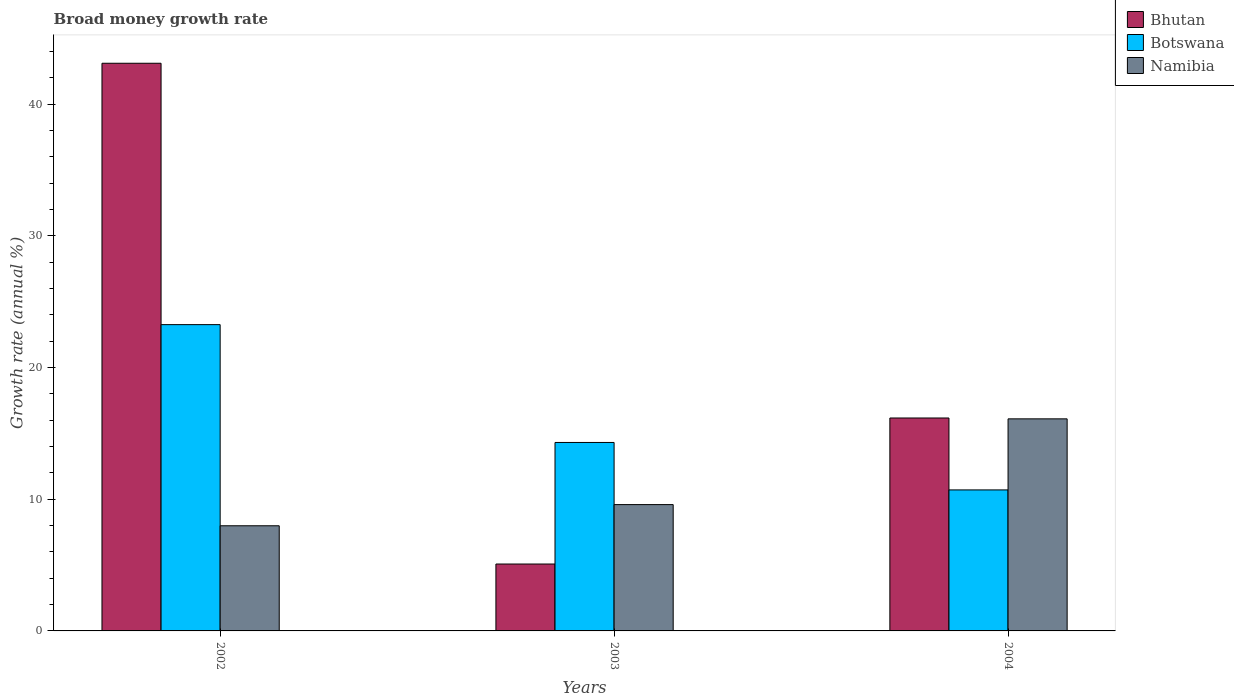How many different coloured bars are there?
Keep it short and to the point. 3. How many groups of bars are there?
Your answer should be very brief. 3. Are the number of bars per tick equal to the number of legend labels?
Keep it short and to the point. Yes. How many bars are there on the 2nd tick from the left?
Your response must be concise. 3. How many bars are there on the 3rd tick from the right?
Give a very brief answer. 3. In how many cases, is the number of bars for a given year not equal to the number of legend labels?
Your answer should be compact. 0. What is the growth rate in Botswana in 2002?
Your response must be concise. 23.26. Across all years, what is the maximum growth rate in Botswana?
Your answer should be compact. 23.26. Across all years, what is the minimum growth rate in Bhutan?
Your response must be concise. 5.08. In which year was the growth rate in Namibia minimum?
Offer a terse response. 2002. What is the total growth rate in Botswana in the graph?
Provide a short and direct response. 48.29. What is the difference between the growth rate in Botswana in 2003 and that in 2004?
Your answer should be compact. 3.6. What is the difference between the growth rate in Namibia in 2003 and the growth rate in Bhutan in 2002?
Make the answer very short. -33.52. What is the average growth rate in Namibia per year?
Offer a terse response. 11.23. In the year 2002, what is the difference between the growth rate in Bhutan and growth rate in Botswana?
Your answer should be very brief. 19.85. In how many years, is the growth rate in Namibia greater than 4 %?
Offer a very short reply. 3. What is the ratio of the growth rate in Bhutan in 2002 to that in 2003?
Keep it short and to the point. 8.49. Is the growth rate in Bhutan in 2002 less than that in 2004?
Offer a very short reply. No. Is the difference between the growth rate in Bhutan in 2002 and 2003 greater than the difference between the growth rate in Botswana in 2002 and 2003?
Make the answer very short. Yes. What is the difference between the highest and the second highest growth rate in Bhutan?
Your answer should be very brief. 26.94. What is the difference between the highest and the lowest growth rate in Bhutan?
Your response must be concise. 38.04. In how many years, is the growth rate in Botswana greater than the average growth rate in Botswana taken over all years?
Make the answer very short. 1. What does the 2nd bar from the left in 2004 represents?
Provide a succinct answer. Botswana. What does the 2nd bar from the right in 2003 represents?
Your response must be concise. Botswana. How many bars are there?
Provide a short and direct response. 9. What is the difference between two consecutive major ticks on the Y-axis?
Ensure brevity in your answer.  10. Are the values on the major ticks of Y-axis written in scientific E-notation?
Ensure brevity in your answer.  No. Does the graph contain any zero values?
Offer a very short reply. No. Does the graph contain grids?
Provide a short and direct response. No. How many legend labels are there?
Your response must be concise. 3. How are the legend labels stacked?
Offer a very short reply. Vertical. What is the title of the graph?
Your answer should be compact. Broad money growth rate. What is the label or title of the X-axis?
Make the answer very short. Years. What is the label or title of the Y-axis?
Your response must be concise. Growth rate (annual %). What is the Growth rate (annual %) in Bhutan in 2002?
Your response must be concise. 43.12. What is the Growth rate (annual %) in Botswana in 2002?
Make the answer very short. 23.26. What is the Growth rate (annual %) in Namibia in 2002?
Your answer should be very brief. 7.99. What is the Growth rate (annual %) in Bhutan in 2003?
Ensure brevity in your answer.  5.08. What is the Growth rate (annual %) in Botswana in 2003?
Your response must be concise. 14.31. What is the Growth rate (annual %) of Namibia in 2003?
Your answer should be very brief. 9.59. What is the Growth rate (annual %) in Bhutan in 2004?
Give a very brief answer. 16.17. What is the Growth rate (annual %) in Botswana in 2004?
Keep it short and to the point. 10.71. What is the Growth rate (annual %) in Namibia in 2004?
Make the answer very short. 16.11. Across all years, what is the maximum Growth rate (annual %) in Bhutan?
Your answer should be compact. 43.12. Across all years, what is the maximum Growth rate (annual %) of Botswana?
Provide a short and direct response. 23.26. Across all years, what is the maximum Growth rate (annual %) of Namibia?
Your answer should be compact. 16.11. Across all years, what is the minimum Growth rate (annual %) of Bhutan?
Offer a terse response. 5.08. Across all years, what is the minimum Growth rate (annual %) of Botswana?
Keep it short and to the point. 10.71. Across all years, what is the minimum Growth rate (annual %) in Namibia?
Provide a succinct answer. 7.99. What is the total Growth rate (annual %) of Bhutan in the graph?
Ensure brevity in your answer.  64.37. What is the total Growth rate (annual %) of Botswana in the graph?
Keep it short and to the point. 48.29. What is the total Growth rate (annual %) of Namibia in the graph?
Ensure brevity in your answer.  33.69. What is the difference between the Growth rate (annual %) of Bhutan in 2002 and that in 2003?
Make the answer very short. 38.04. What is the difference between the Growth rate (annual %) in Botswana in 2002 and that in 2003?
Provide a short and direct response. 8.95. What is the difference between the Growth rate (annual %) of Namibia in 2002 and that in 2003?
Offer a terse response. -1.61. What is the difference between the Growth rate (annual %) in Bhutan in 2002 and that in 2004?
Give a very brief answer. 26.94. What is the difference between the Growth rate (annual %) of Botswana in 2002 and that in 2004?
Your answer should be compact. 12.55. What is the difference between the Growth rate (annual %) of Namibia in 2002 and that in 2004?
Keep it short and to the point. -8.12. What is the difference between the Growth rate (annual %) of Bhutan in 2003 and that in 2004?
Provide a succinct answer. -11.09. What is the difference between the Growth rate (annual %) in Botswana in 2003 and that in 2004?
Your answer should be compact. 3.6. What is the difference between the Growth rate (annual %) in Namibia in 2003 and that in 2004?
Offer a very short reply. -6.51. What is the difference between the Growth rate (annual %) in Bhutan in 2002 and the Growth rate (annual %) in Botswana in 2003?
Your answer should be very brief. 28.8. What is the difference between the Growth rate (annual %) of Bhutan in 2002 and the Growth rate (annual %) of Namibia in 2003?
Give a very brief answer. 33.52. What is the difference between the Growth rate (annual %) of Botswana in 2002 and the Growth rate (annual %) of Namibia in 2003?
Offer a terse response. 13.67. What is the difference between the Growth rate (annual %) in Bhutan in 2002 and the Growth rate (annual %) in Botswana in 2004?
Ensure brevity in your answer.  32.41. What is the difference between the Growth rate (annual %) of Bhutan in 2002 and the Growth rate (annual %) of Namibia in 2004?
Offer a terse response. 27.01. What is the difference between the Growth rate (annual %) of Botswana in 2002 and the Growth rate (annual %) of Namibia in 2004?
Offer a very short reply. 7.16. What is the difference between the Growth rate (annual %) in Bhutan in 2003 and the Growth rate (annual %) in Botswana in 2004?
Ensure brevity in your answer.  -5.63. What is the difference between the Growth rate (annual %) of Bhutan in 2003 and the Growth rate (annual %) of Namibia in 2004?
Your response must be concise. -11.03. What is the difference between the Growth rate (annual %) of Botswana in 2003 and the Growth rate (annual %) of Namibia in 2004?
Your response must be concise. -1.79. What is the average Growth rate (annual %) of Bhutan per year?
Offer a very short reply. 21.46. What is the average Growth rate (annual %) in Botswana per year?
Provide a succinct answer. 16.1. What is the average Growth rate (annual %) in Namibia per year?
Make the answer very short. 11.23. In the year 2002, what is the difference between the Growth rate (annual %) in Bhutan and Growth rate (annual %) in Botswana?
Make the answer very short. 19.85. In the year 2002, what is the difference between the Growth rate (annual %) of Bhutan and Growth rate (annual %) of Namibia?
Provide a succinct answer. 35.13. In the year 2002, what is the difference between the Growth rate (annual %) in Botswana and Growth rate (annual %) in Namibia?
Your response must be concise. 15.28. In the year 2003, what is the difference between the Growth rate (annual %) in Bhutan and Growth rate (annual %) in Botswana?
Make the answer very short. -9.23. In the year 2003, what is the difference between the Growth rate (annual %) in Bhutan and Growth rate (annual %) in Namibia?
Make the answer very short. -4.51. In the year 2003, what is the difference between the Growth rate (annual %) in Botswana and Growth rate (annual %) in Namibia?
Your answer should be very brief. 4.72. In the year 2004, what is the difference between the Growth rate (annual %) in Bhutan and Growth rate (annual %) in Botswana?
Your answer should be compact. 5.46. In the year 2004, what is the difference between the Growth rate (annual %) in Bhutan and Growth rate (annual %) in Namibia?
Make the answer very short. 0.07. In the year 2004, what is the difference between the Growth rate (annual %) in Botswana and Growth rate (annual %) in Namibia?
Offer a very short reply. -5.4. What is the ratio of the Growth rate (annual %) of Bhutan in 2002 to that in 2003?
Your response must be concise. 8.49. What is the ratio of the Growth rate (annual %) in Botswana in 2002 to that in 2003?
Provide a succinct answer. 1.63. What is the ratio of the Growth rate (annual %) of Namibia in 2002 to that in 2003?
Offer a very short reply. 0.83. What is the ratio of the Growth rate (annual %) in Bhutan in 2002 to that in 2004?
Provide a succinct answer. 2.67. What is the ratio of the Growth rate (annual %) in Botswana in 2002 to that in 2004?
Provide a short and direct response. 2.17. What is the ratio of the Growth rate (annual %) of Namibia in 2002 to that in 2004?
Ensure brevity in your answer.  0.5. What is the ratio of the Growth rate (annual %) in Bhutan in 2003 to that in 2004?
Offer a very short reply. 0.31. What is the ratio of the Growth rate (annual %) in Botswana in 2003 to that in 2004?
Provide a succinct answer. 1.34. What is the ratio of the Growth rate (annual %) in Namibia in 2003 to that in 2004?
Make the answer very short. 0.6. What is the difference between the highest and the second highest Growth rate (annual %) of Bhutan?
Make the answer very short. 26.94. What is the difference between the highest and the second highest Growth rate (annual %) of Botswana?
Keep it short and to the point. 8.95. What is the difference between the highest and the second highest Growth rate (annual %) in Namibia?
Offer a terse response. 6.51. What is the difference between the highest and the lowest Growth rate (annual %) in Bhutan?
Keep it short and to the point. 38.04. What is the difference between the highest and the lowest Growth rate (annual %) in Botswana?
Give a very brief answer. 12.55. What is the difference between the highest and the lowest Growth rate (annual %) of Namibia?
Your response must be concise. 8.12. 